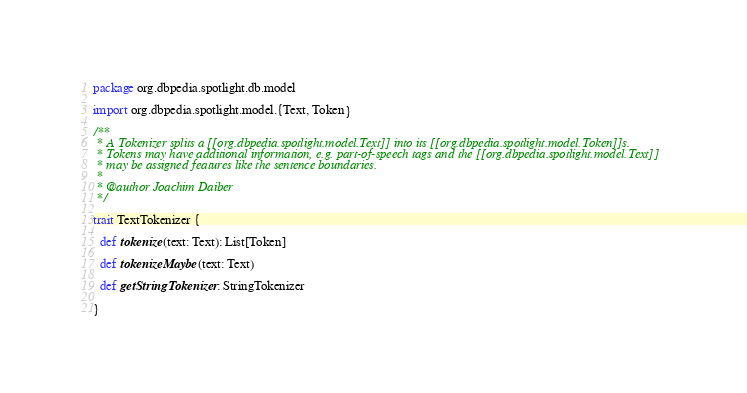<code> <loc_0><loc_0><loc_500><loc_500><_Scala_>package org.dbpedia.spotlight.db.model

import org.dbpedia.spotlight.model.{Text, Token}

/**
 * A Tokenizer splits a [[org.dbpedia.spotlight.model.Text]] into its [[org.dbpedia.spotlight.model.Token]]s.
 * Tokens may have additional information, e.g. part-of-speech tags and the [[org.dbpedia.spotlight.model.Text]]
 * may be assigned features like the sentence boundaries.
 *
 * @author Joachim Daiber
 */

trait TextTokenizer {

  def tokenize(text: Text): List[Token]

  def tokenizeMaybe(text: Text)

  def getStringTokenizer: StringTokenizer

}
</code> 